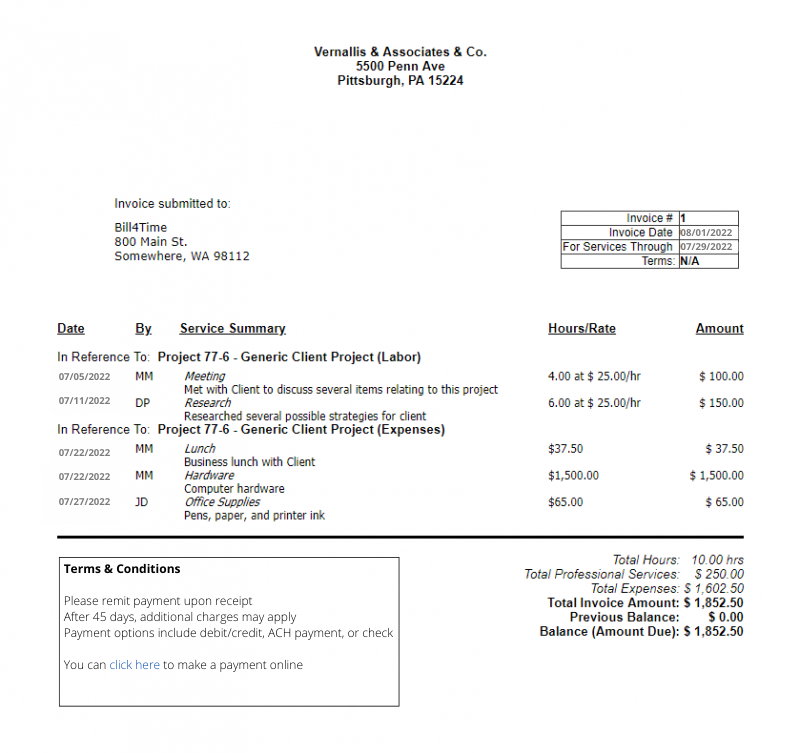extract  a list of all order items on that invoice, stating their Quantity, unit price and total amount the following json format: 
```
{{
    \"TabOrderItems\": [
        {{
            \"OrdItmArticleNo\": \"\",
            \"OrdItmArticleDescription\": \"\",
            \"OrdItmQuantity\": 2.0,
            \"OrdItemSingleNetAmount\": 3.34,
            \"OrdItemTotalNetAmount\": 4.23
        }}
    ]
}}
```

Include only goods and services, ignore shipping fees, taxes etc.
Only use the provided data. If you don't find some of the values within the provided data leave it blank.
 ```json
{
    "TabOrderItems": [
        {
            "OrdItmArticleNo": "",
            "OrdItmArticleDescription": "Meeting",
            "OrdItmQuantity": 4.0,
            "OrdItemSingleNetAmount": 25.0,
            "OrdItemTotalNetAmount": 100.0
        },
        {
            "OrdItmArticleNo": "",
            "OrdItmArticleDescription": "Research",
            "OrdItmQuantity": 6.0,
            "OrdItemSingleNetAmount": 25.0,
            "OrdItemTotalNetAmount": 150.0
        },
        {
            "OrdItmArticleNo": "",
            "OrdItmArticleDescription": "Lunch",
            "OrdItmQuantity": 1.0,
            "OrdItemSingleNetAmount": 37.5,
            "OrdItemTotalNetAmount": 37.5
        },
        {
            "OrdItmArticleNo": "",
            "OrdItmArticleDescription": "Hardware",
            "OrdItmQuantity": 1.0,
            "OrdItemSingleNetAmount": 65.0,
            "OrdItemTotalNetAmount": 65.0
        },
        {
            "OrdItmArticleNo": "",
            "OrdItmArticleDescription": "Computer hardware",
            "OrdItmQuantity": 1.0,
            "OrdItemSingleNetAmount": 1500.0,
            "OrdItemTotalNetAmount": 1500.0
        },
        {
            "OrdItmArticleNo": "",
            "OrdItmArticleDescription": "Pens, paper, and printer ink",
            "OrdItmQuantity": 1.0,
            "OrdItemSingleNetAmount": 65.0,
            "OrdItemTotalNetAmount": 65.0
        }
    ]
}
``` 